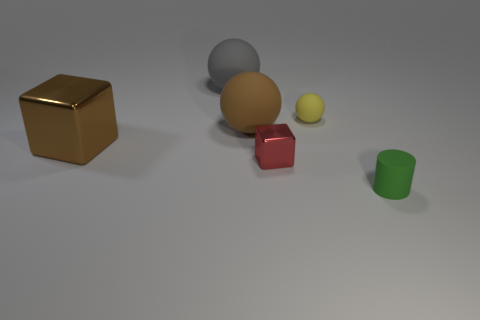Can you describe the textures of the different objects present? Certainly! Starting from the left, the cube appears to have a shiny, metallic surface. The large and small spheres seem matte, with no reflective glare, indicating a rougher texture. The red cube has a rubbery look, with a hint of soft light reflection, while the last object—a green cylinder—appears to have a slightly reflective plastic finish. 